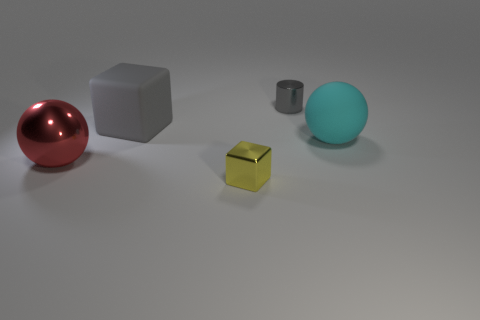Add 4 large green blocks. How many objects exist? 9 Subtract all balls. How many objects are left? 3 Subtract 1 yellow blocks. How many objects are left? 4 Subtract all large gray objects. Subtract all big red metal things. How many objects are left? 3 Add 2 yellow metallic cubes. How many yellow metallic cubes are left? 3 Add 1 green matte things. How many green matte things exist? 1 